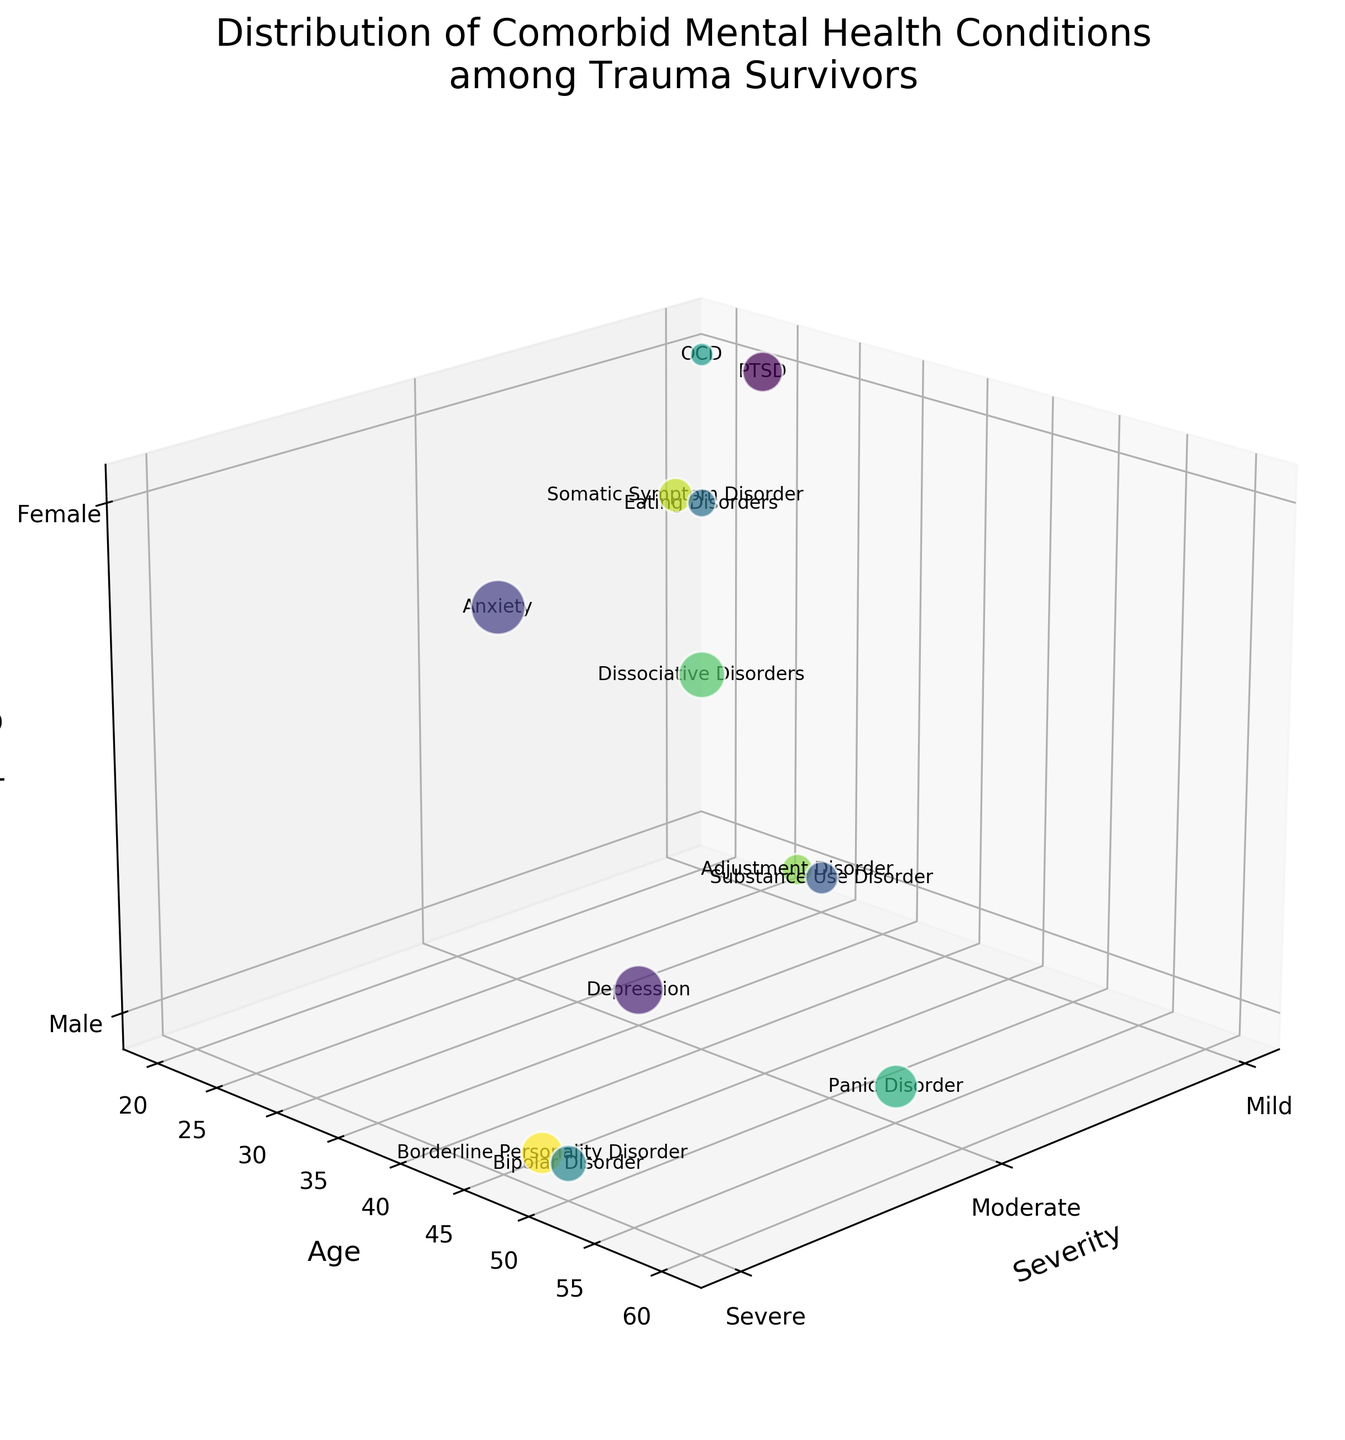What's the title of the chart? The title is usually displayed at the top, directly above the figure. Here, the first text you encounter above the plot is "Distribution of Comorbid Mental Health Conditions among Trauma Survivors."
Answer: Distribution of Comorbid Mental Health Conditions among Trauma Survivors Which condition has the highest prevalence among females? Looking at the bubbles where the gender axis equals "Female" (z-axis marked as 2), the bubble with the largest size is for "Anxiety," with a prevalence of 55.
Answer: Anxiety How many conditions have a prevalence above 30? Count the bubbles with a size representing prevalence higher than 30. There are 6 such bubbles: PTSD, Depression, Anxiety, Panic Disorder, Dissociative Disorders, and Borderline Personality Disorder.
Answer: 6 What age group shows the highest severity for Bipolar Disorder? Find the bubble labeled "Bipolar Disorder" and observe its position on the severity (x-axis) and age (y-axis). It is located at "Severe" (3) and the age is 50.
Answer: 50 Which mental health condition occurs in males in their mid-30s and has moderate severity? Look for a bubble at the moderate severity level (x=2), male gender (z=1), and age around 35. The bubble corresponding to these criteria is "Depression".
Answer: Depression Compare the prevalence of Substance Use Disorder in males vs. the prevalence of OCD in females. Which is higher? Locate the two bubbles: "Substance Use Disorder" and "OCD". "Substance Use Disorder" has a prevalence of 20 while "OCD" has a prevalence of 10. 20 is higher than 10.
Answer: Substance Use Disorder Which gender has a higher number of mental health conditions in the severe category? Count the number of bubbles at the severe severity level (x=3) for both genders. There are 2 for Males (Bipolar Disorder, Borderline Personality Disorder) and 3 for Females (Anxiety, Dissociative Disorders).
Answer: Female What is the total prevalence of conditions in the mild category? Sum the prevalence values for conditions classified under "Mild" severity: 30 (PTSD) + 20 (Substance Use Disorder) + 10 (OCD) + 18 (Adjustment Disorder) = 78
Answer: 78 At what age are males most affected by Panic Disorder? Locate the bubble labeled "Panic Disorder" and identify the age (y-axis) and the gender (z-axis should be 1 for males). The age is 55.
Answer: 55 